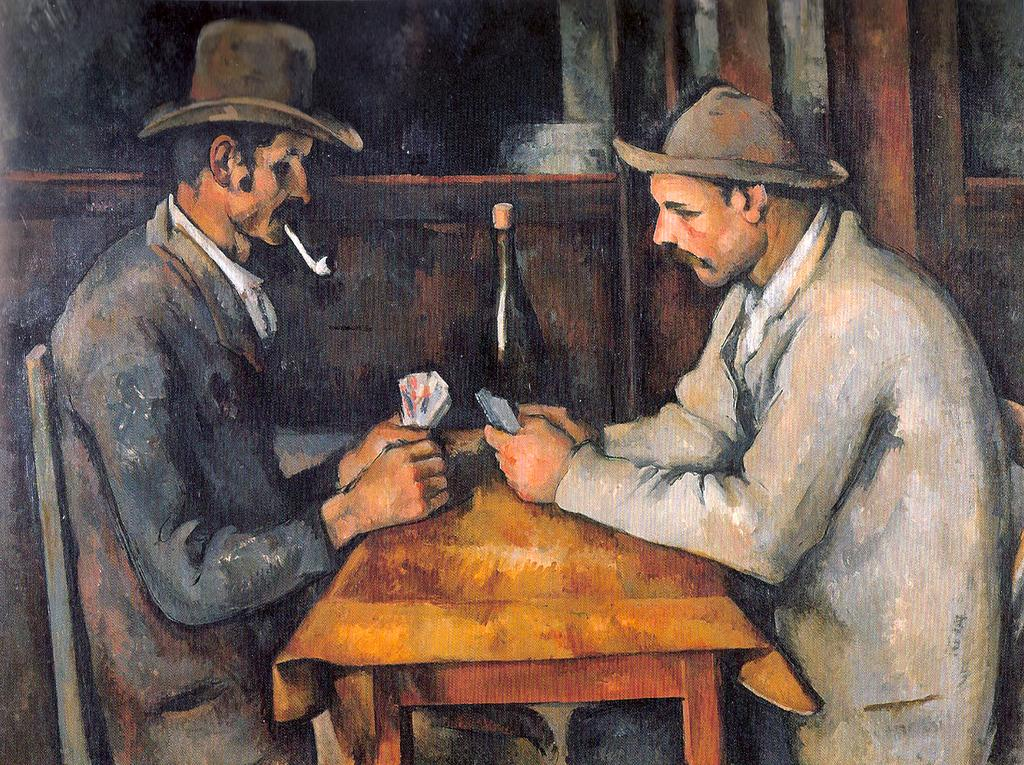What type of artwork is depicted in the image? The image is a painting. How many people are present in the painting? There are two persons in the image. What are the persons doing in the painting? The persons are sitting at a table and playing cards. What can be seen in the background of the painting? There is a bottle and a wall in the background of the image. What type of attraction can be seen in the background of the painting? There is no attraction present in the background of the painting; it only features a bottle and a wall. What type of tail is visible on one of the persons in the painting? There are no tails visible on either of the persons in the painting. 